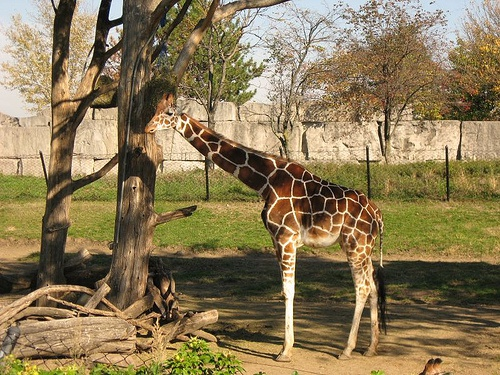Describe the objects in this image and their specific colors. I can see a giraffe in lightgray, black, maroon, olive, and brown tones in this image. 